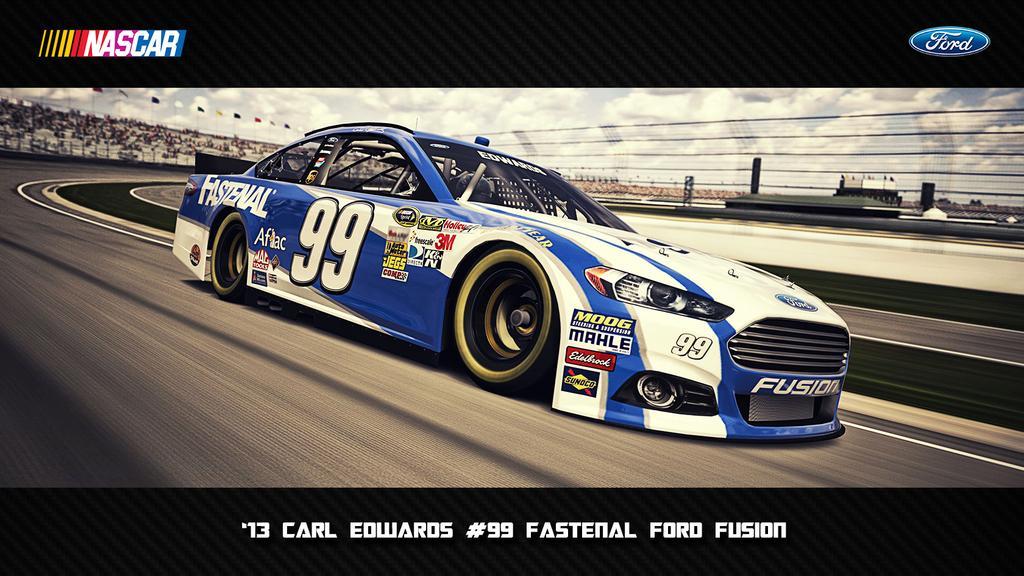Describe this image in one or two sentences. In this picture we can see a car on the road, flags, fence, logos and some objects and in the background we can see the sky with clouds. 